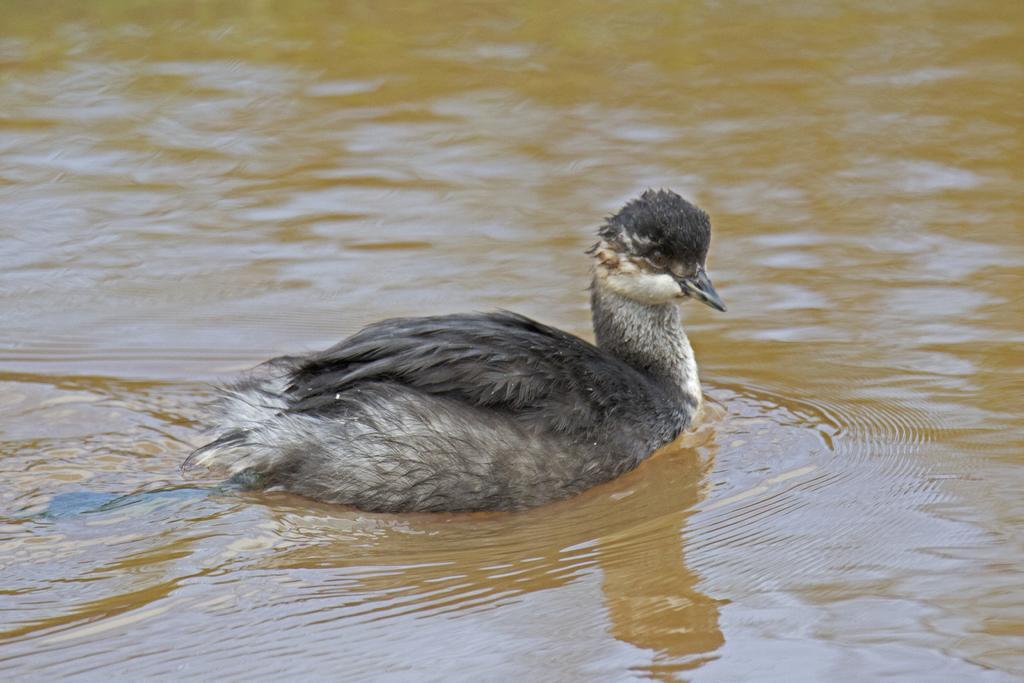Could you give a brief overview of what you see in this image? In this image in the center there is a bird, and at the bottom there is a river. 